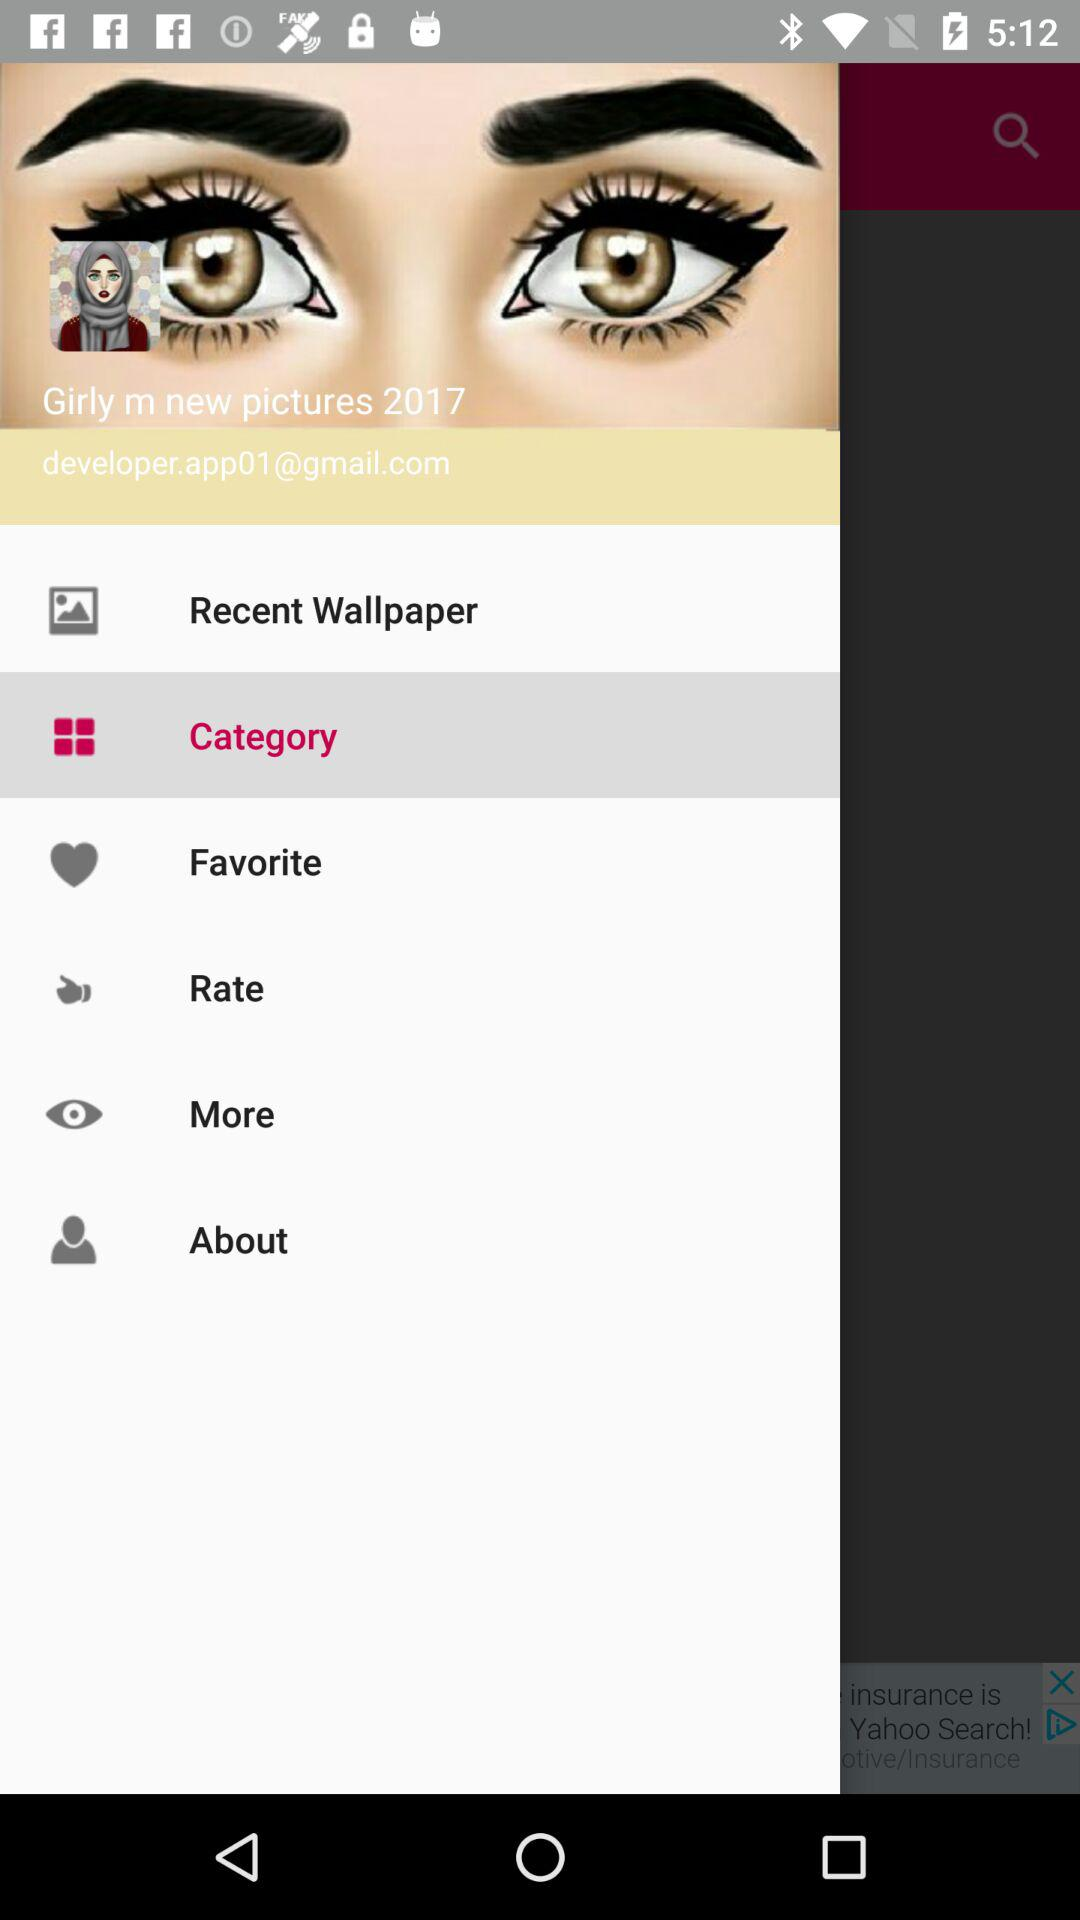For which year the pictures are?
When the provided information is insufficient, respond with <no answer>. <no answer> 